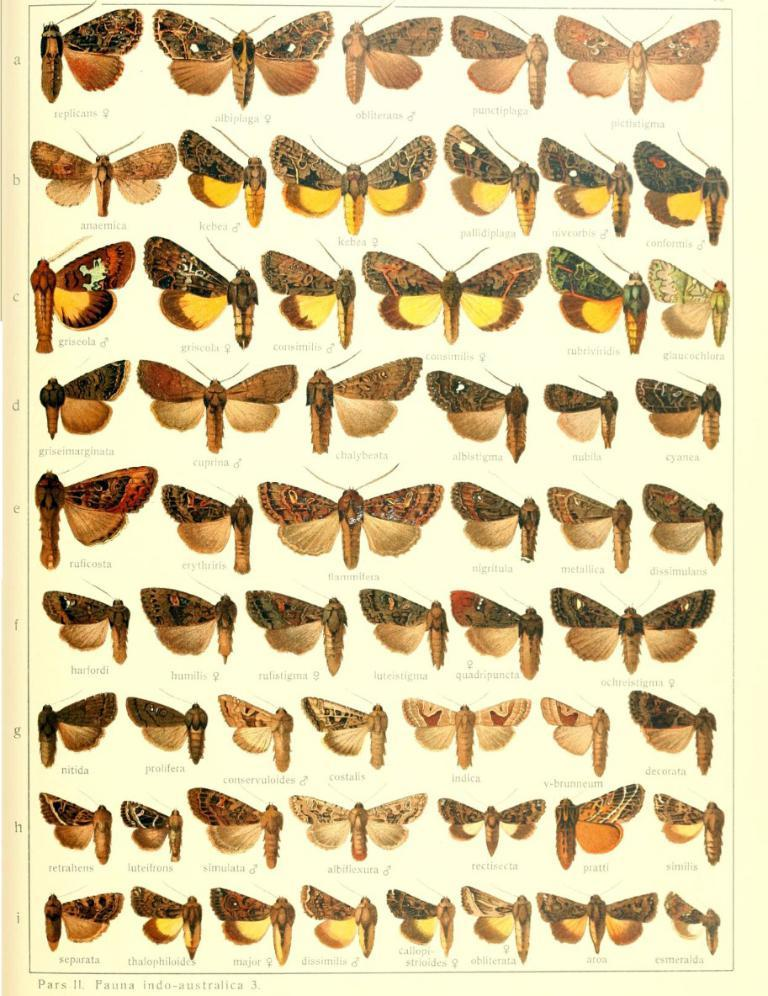What type of animals are depicted in the picture? There are images of butterflies in the picture. Are there any words or letters on the butterflies? Yes, there is text on each butterfly. How much does the cannon weigh in the image? There is no cannon present in the image. What type of cushion is used to support the butterflies in the image? There is no cushion mentioned or depicted in the image; the butterflies are likely just images or illustrations. 